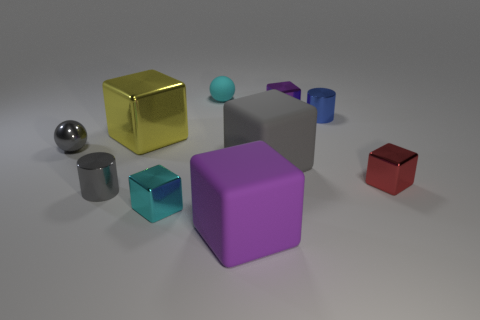Subtract all purple cubes. How many cubes are left? 4 Subtract all big purple cubes. How many cubes are left? 5 Subtract all red cubes. Subtract all cyan cylinders. How many cubes are left? 5 Subtract all balls. How many objects are left? 8 Add 5 purple matte blocks. How many purple matte blocks exist? 6 Subtract 1 cyan spheres. How many objects are left? 9 Subtract all tiny cylinders. Subtract all red metal things. How many objects are left? 7 Add 4 tiny cubes. How many tiny cubes are left? 7 